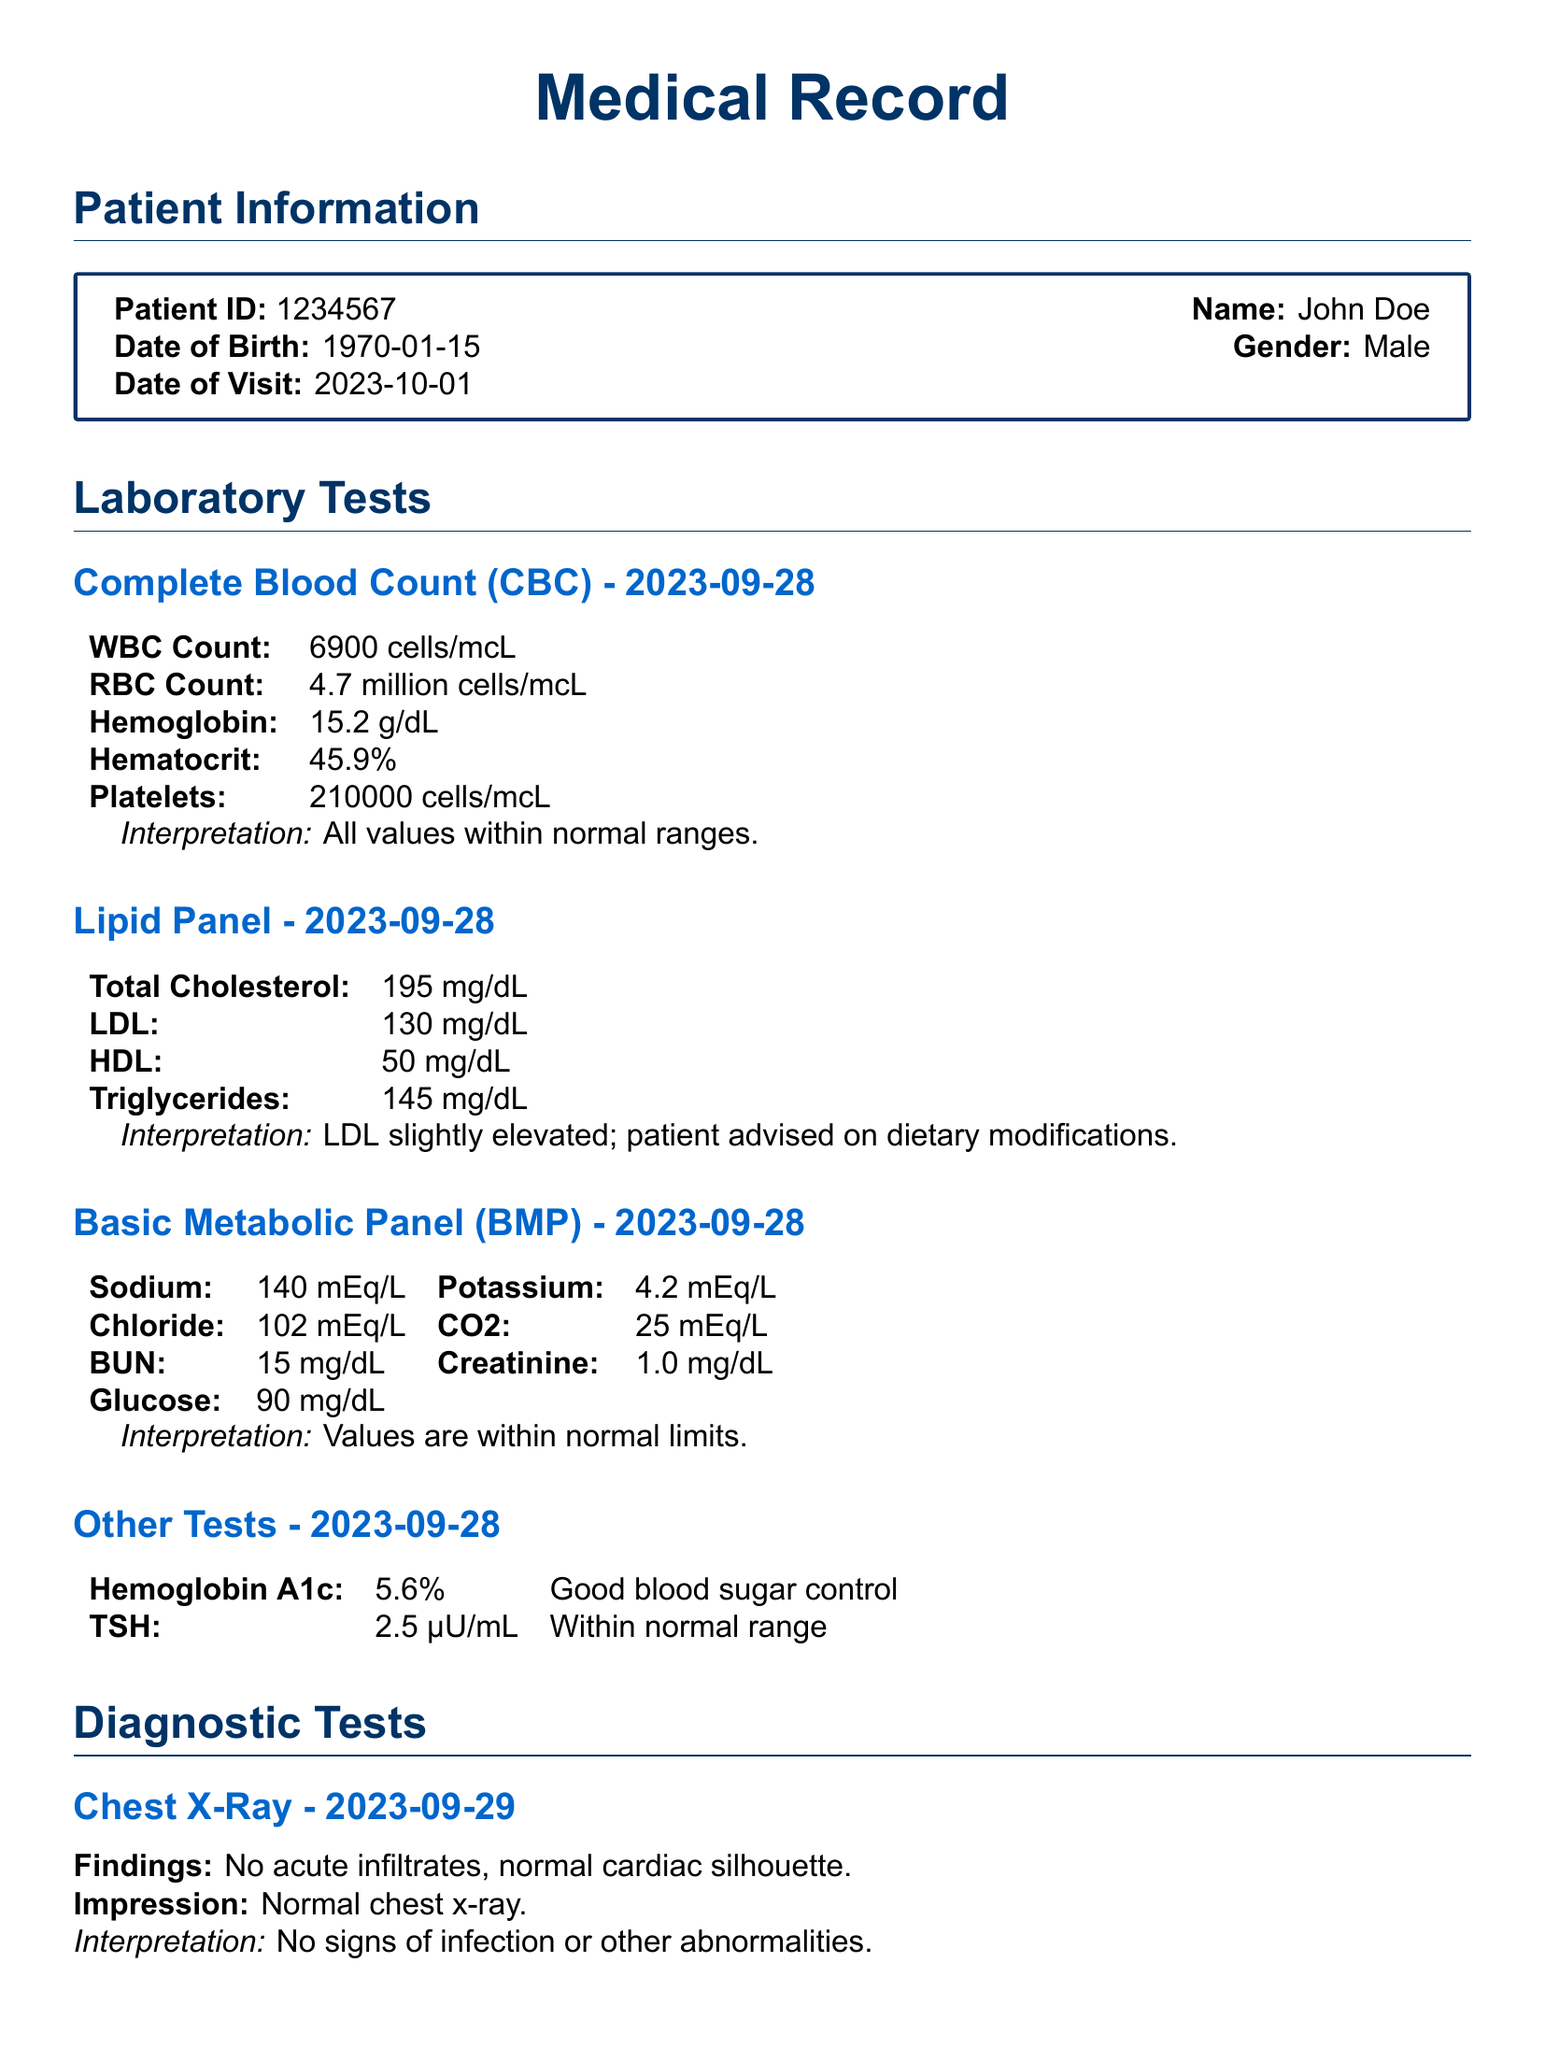What is the patient's name? The name of the patient is provided in the patient information section of the document.
Answer: John Doe What was the date of the lipid panel test? The date for the lipid panel test is specifically mentioned under the laboratory tests section.
Answer: 2023-09-28 What is the patient's LDL cholesterol level? The LDL cholesterol level is recorded under the lipid panel test results.
Answer: 130 mg/dL What was the impression from the chest X-ray? The impression from the chest X-ray is stated under the diagnostic tests section.
Answer: Normal chest x-ray What is the interpretation of the Complete Blood Count? The interpretation of the CBC is included after the results of the test in the document.
Answer: All values within normal ranges What is the result of the TSH test? The result of the TSH test is mentioned under other tests in the document.
Answer: 2.5 µU/mL What follow-up action is advised for the patient's LDL level? The follow-up action regarding the elevated LDL is provided in the lipid panel interpretation.
Answer: Dietary modifications What is the patient's age? The patient's age can be calculated based on the date of birth provided in the document.
Answer: 53 years What was the heart rate recorded in the ECG? The heart rate from the ECG is noted in the diagnostic tests section.
Answer: 72 bpm 